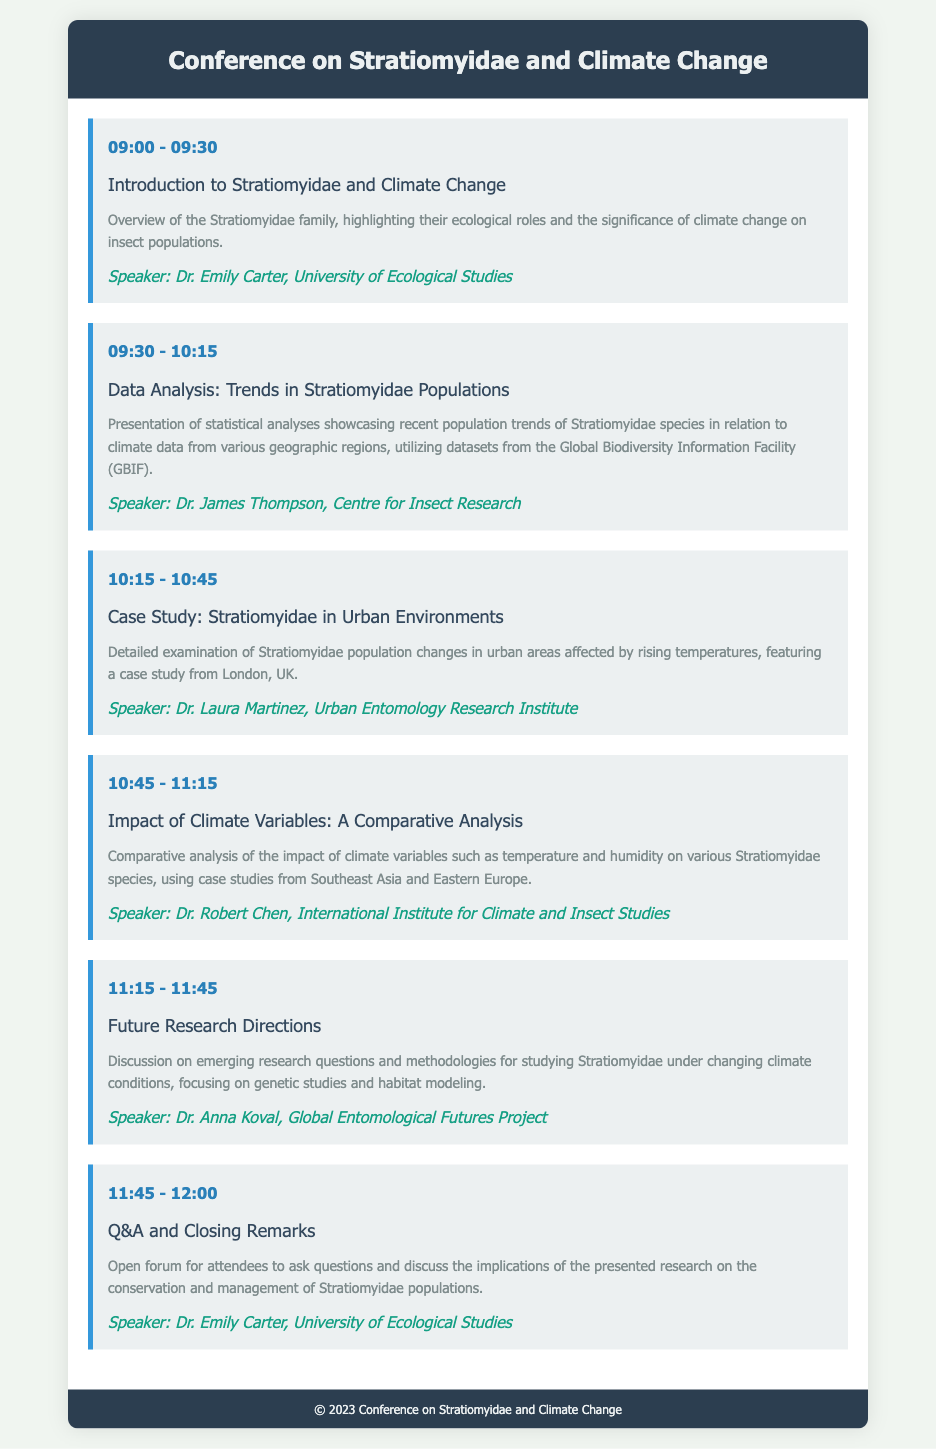what time does the conference start? The conference starts with the first session at 09:00.
Answer: 09:00 who is the speaker for the session on data analysis? The speaker for the session on data analysis is Dr. James Thompson.
Answer: Dr. James Thompson what is the title of the case study session? The title of the case study session is "Case Study: Stratiomyidae in Urban Environments."
Answer: Case Study: Stratiomyidae in Urban Environments which session discusses future research directions? The session discussing future research directions is titled "Future Research Directions."
Answer: Future Research Directions how long is the Q&A and Closing Remarks session? The Q&A and Closing Remarks session lasts for 15 minutes, from 11:45 to 12:00.
Answer: 15 minutes what is the main focus of the conference? The main focus of the conference is the impact of climate change on Stratiomyidae populations.
Answer: impact of climate change on Stratiomyidae populations which geographic regions are analyzed in the comparative analysis session? The comparative analysis session uses case studies from Southeast Asia and Eastern Europe.
Answer: Southeast Asia and Eastern Europe who gives the introduction to Stratiomyidae and climate change? The introduction session is given by Dr. Emily Carter.
Answer: Dr. Emily Carter 